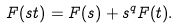Convert formula to latex. <formula><loc_0><loc_0><loc_500><loc_500>F ( s t ) = F ( s ) + s ^ { q } F ( t ) .</formula> 